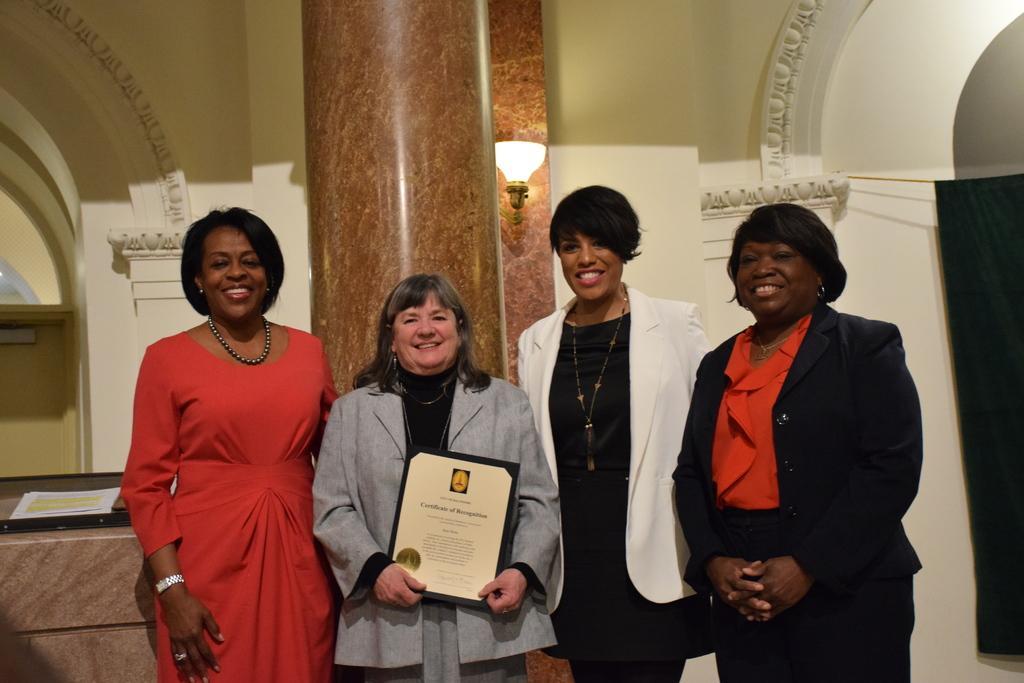Describe this image in one or two sentences. In this picture we can see four women standing and smiling were a woman holding a frame with her hands and at the back of her we can see a pillar, light, papers, arch, curtain and the wall. 